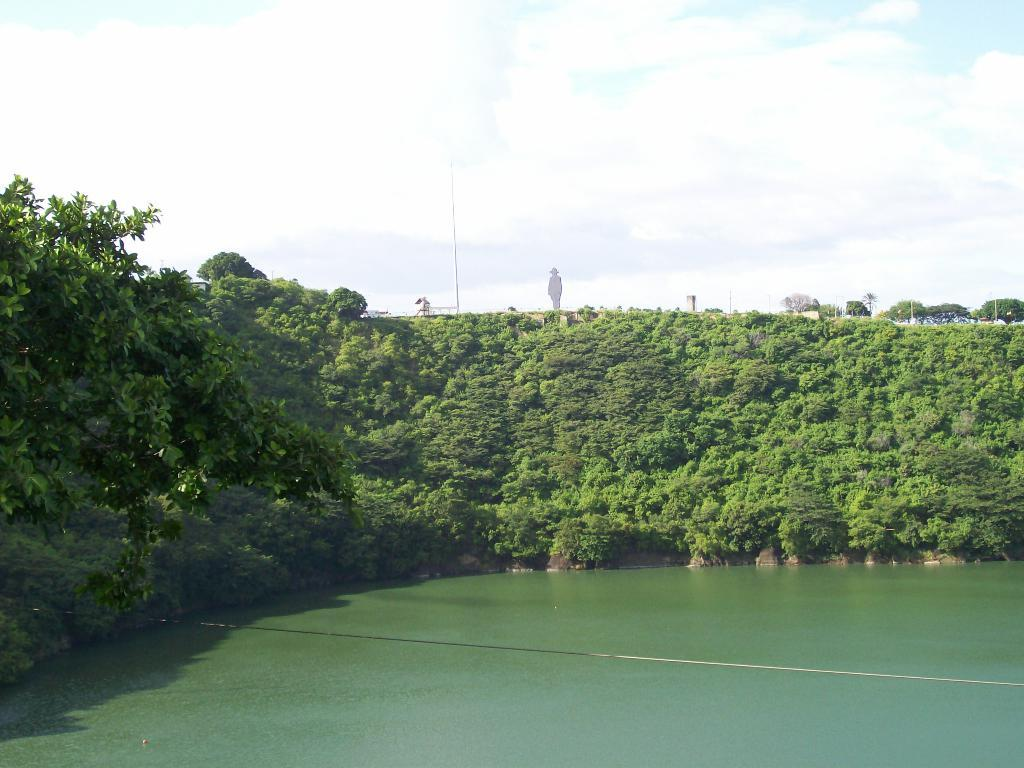What is visible in the image? Water is visible in the image. What can be seen in the background of the image? In the background of the image, there are plants, many trees, poles, clouds in the sky, and the sky itself. How does the board help the achiever in the image? There is no board or achiever present in the image. 